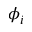Convert formula to latex. <formula><loc_0><loc_0><loc_500><loc_500>\phi _ { i }</formula> 